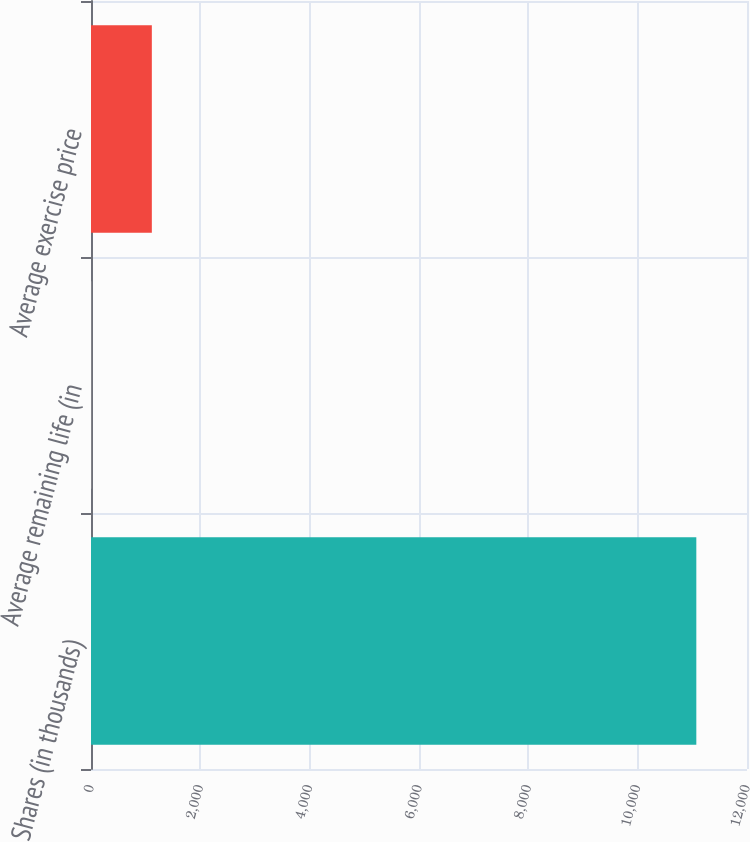Convert chart to OTSL. <chart><loc_0><loc_0><loc_500><loc_500><bar_chart><fcel>Shares (in thousands)<fcel>Average remaining life (in<fcel>Average exercise price<nl><fcel>11073<fcel>6.2<fcel>1112.88<nl></chart> 